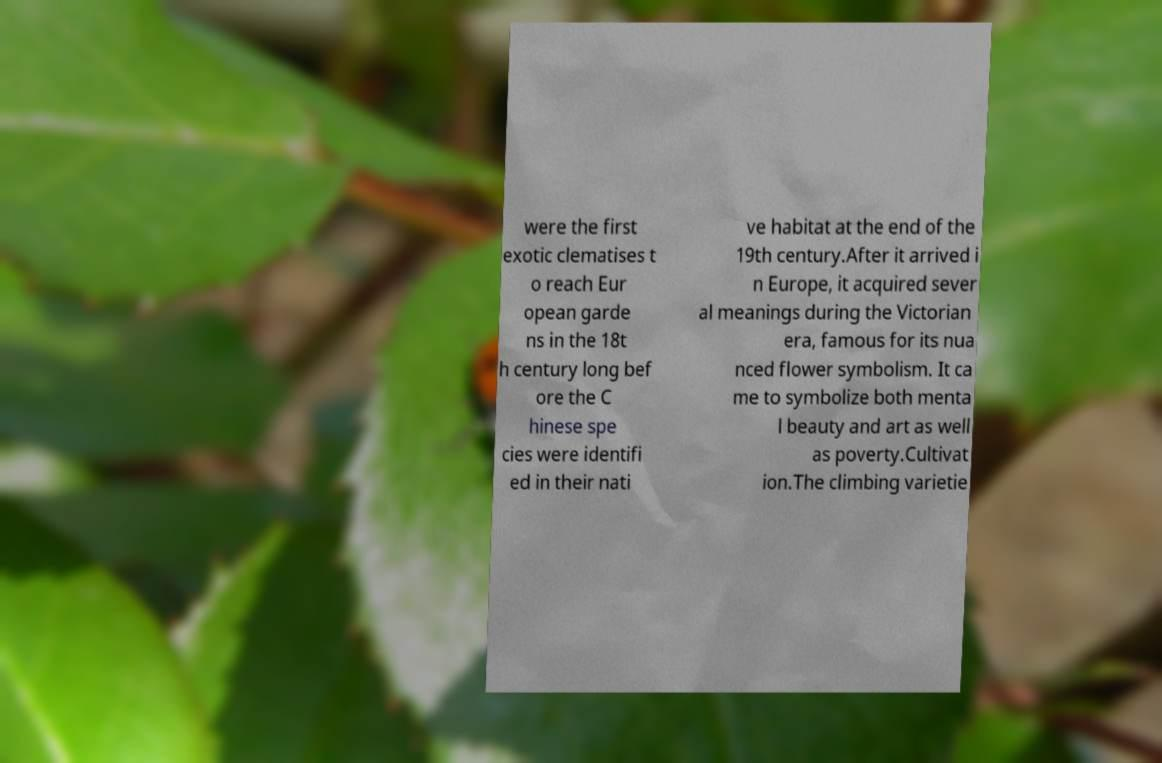What messages or text are displayed in this image? I need them in a readable, typed format. were the first exotic clematises t o reach Eur opean garde ns in the 18t h century long bef ore the C hinese spe cies were identifi ed in their nati ve habitat at the end of the 19th century.After it arrived i n Europe, it acquired sever al meanings during the Victorian era, famous for its nua nced flower symbolism. It ca me to symbolize both menta l beauty and art as well as poverty.Cultivat ion.The climbing varietie 